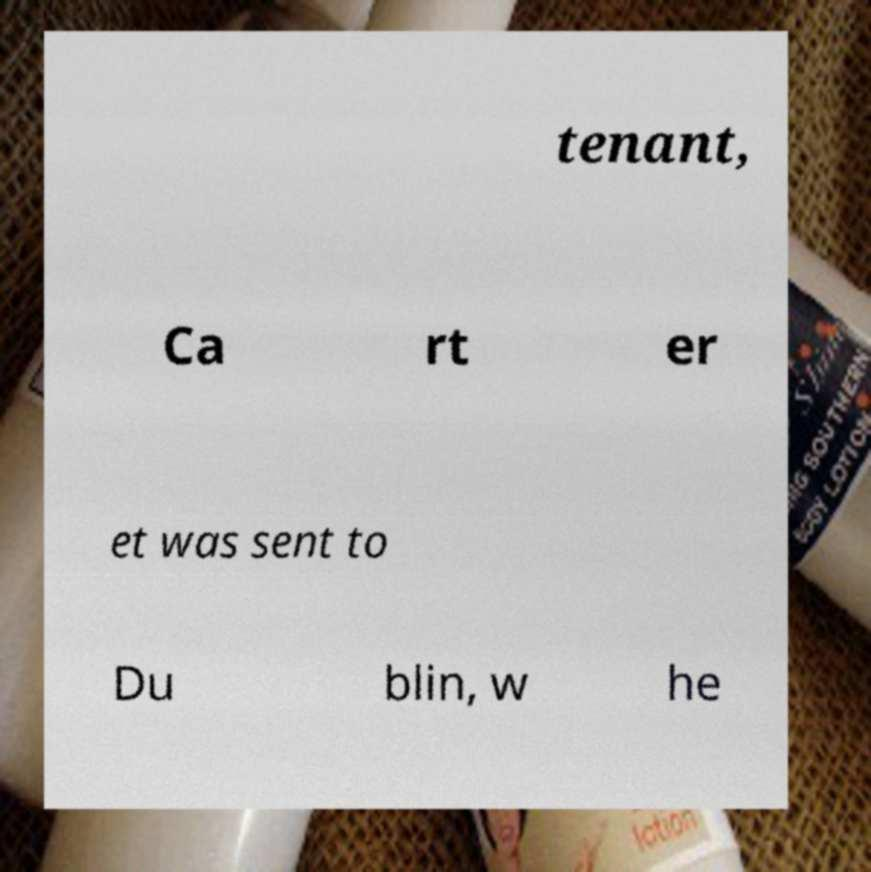Please identify and transcribe the text found in this image. tenant, Ca rt er et was sent to Du blin, w he 